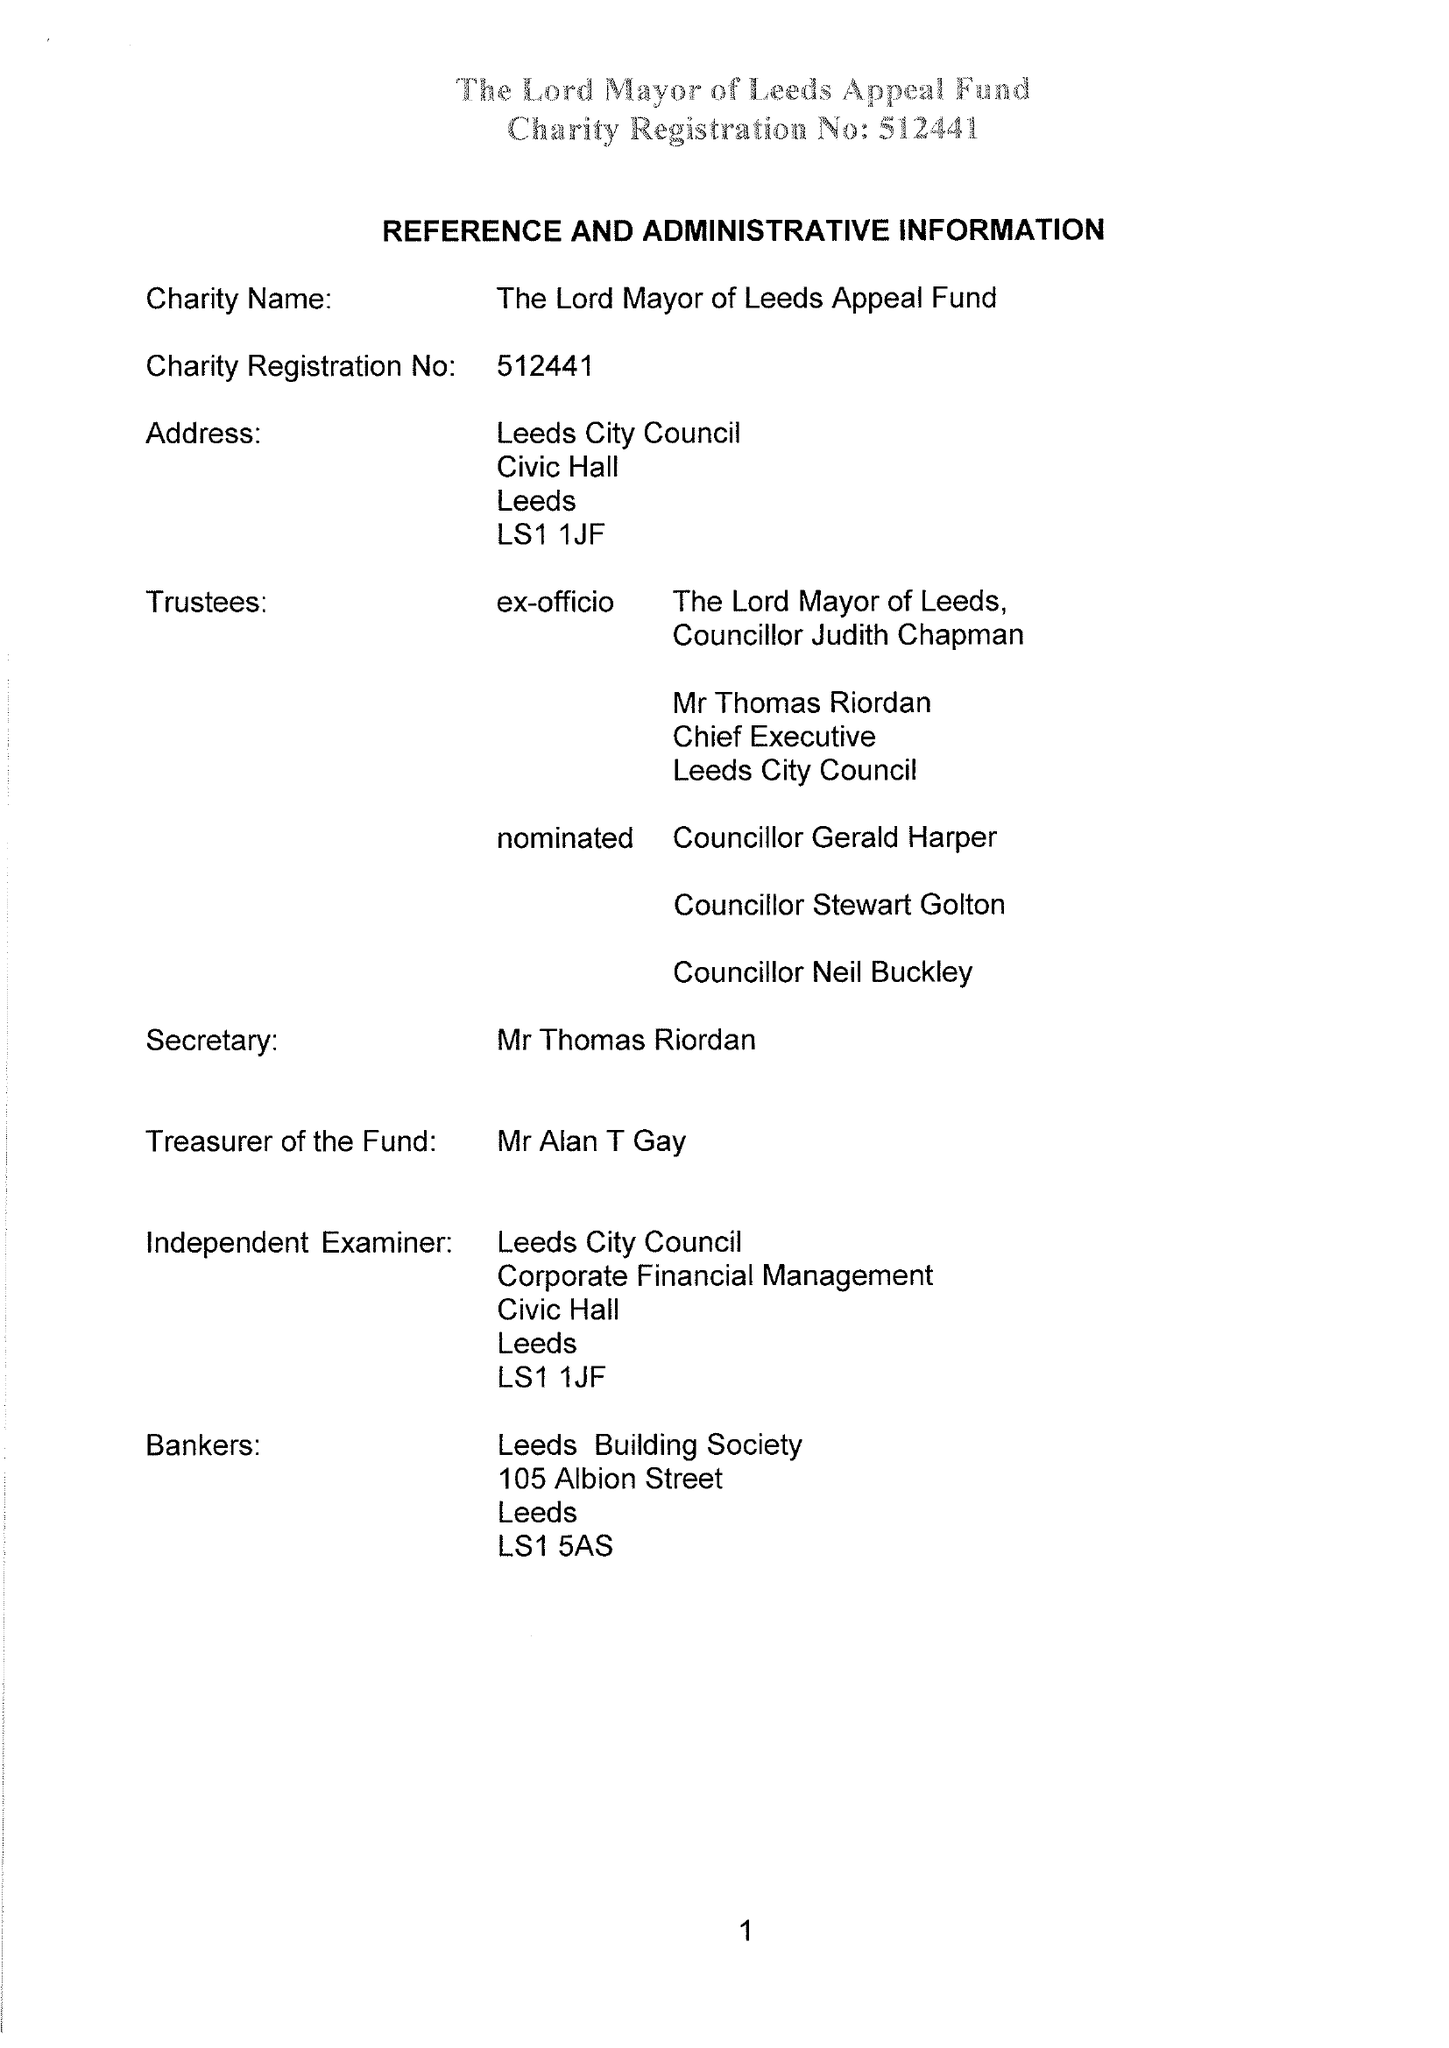What is the value for the charity_name?
Answer the question using a single word or phrase. Lord Mayor Of Leeds Appeal Fund 